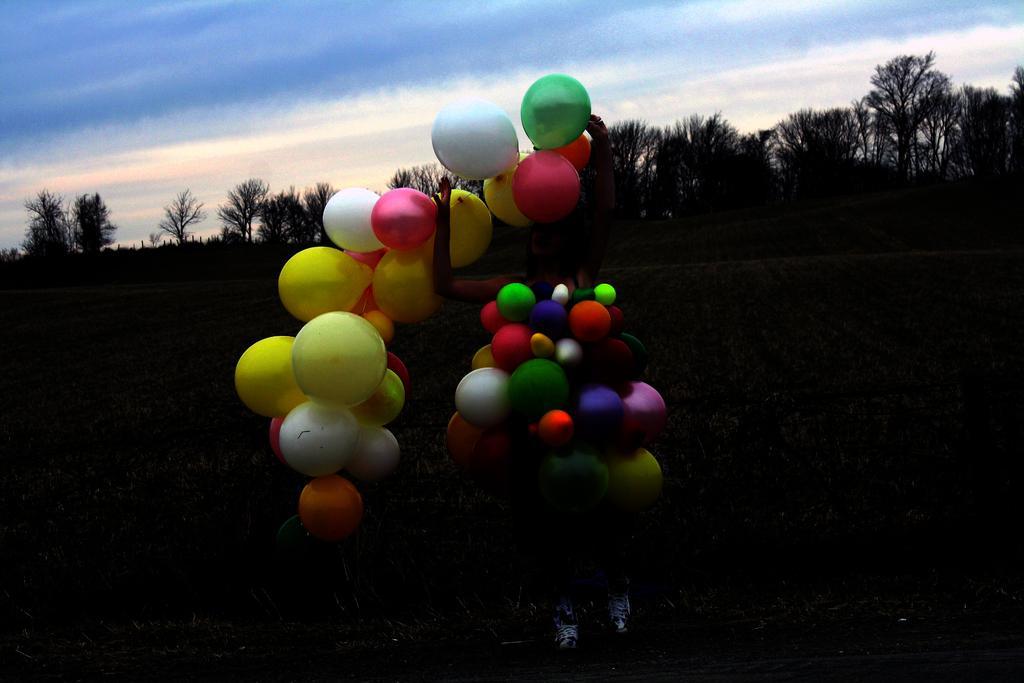Please provide a concise description of this image. In this picture, we can see a person holding a few balloons, and we can see the ground, trees, and the sky with clouds. 